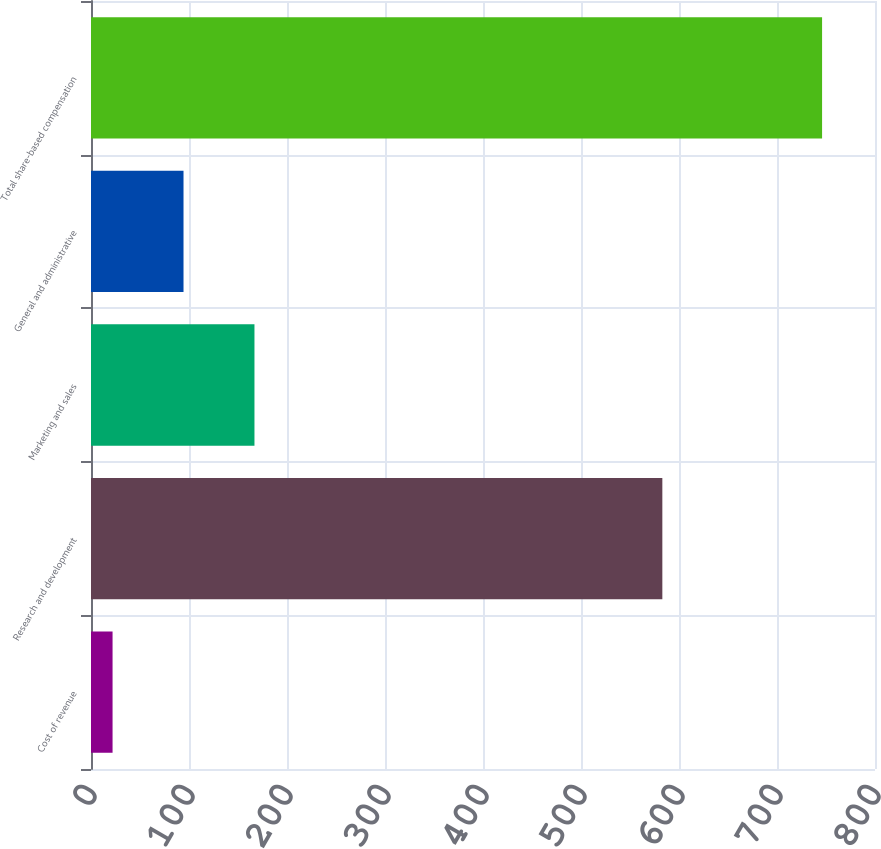Convert chart to OTSL. <chart><loc_0><loc_0><loc_500><loc_500><bar_chart><fcel>Cost of revenue<fcel>Research and development<fcel>Marketing and sales<fcel>General and administrative<fcel>Total share-based compensation<nl><fcel>22<fcel>583<fcel>166.8<fcel>94.4<fcel>746<nl></chart> 